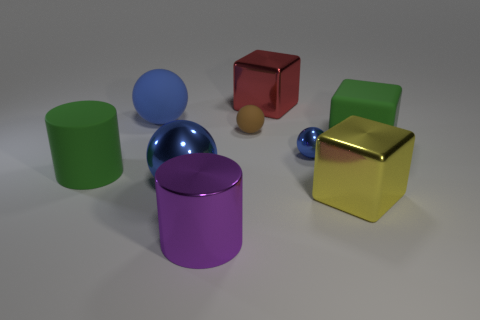Subtract all red cubes. How many cubes are left? 2 Subtract all green cubes. How many cubes are left? 2 Subtract 4 spheres. How many spheres are left? 0 Subtract all cyan cylinders. How many green balls are left? 0 Subtract all spheres. How many objects are left? 5 Subtract all green cubes. Subtract all brown cylinders. How many cubes are left? 2 Subtract all big rubber cubes. Subtract all brown things. How many objects are left? 7 Add 7 large blue matte balls. How many large blue matte balls are left? 8 Add 3 large rubber things. How many large rubber things exist? 6 Subtract 0 red cylinders. How many objects are left? 9 